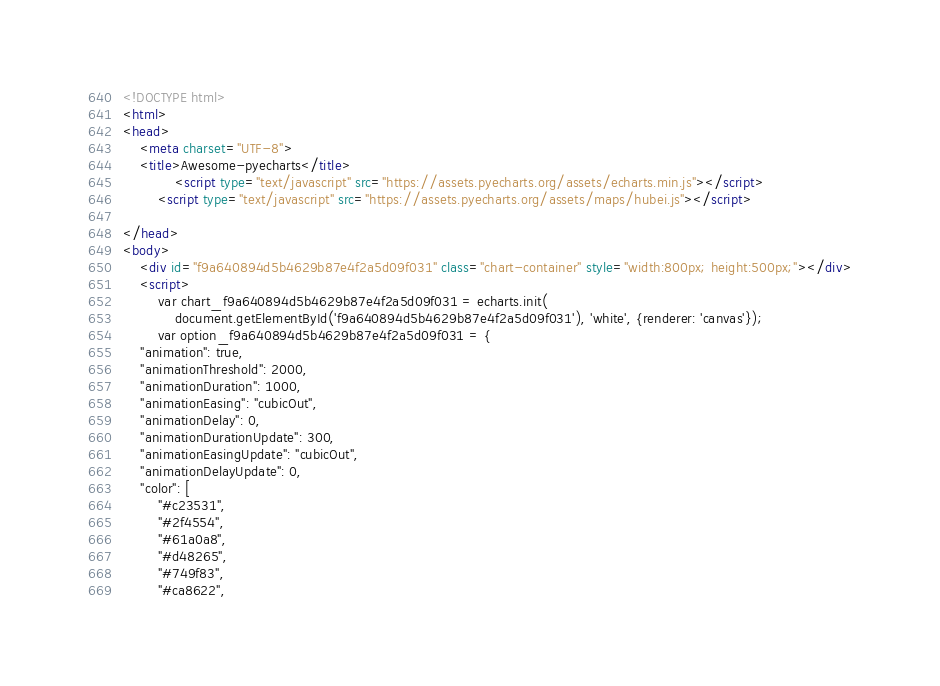<code> <loc_0><loc_0><loc_500><loc_500><_HTML_><!DOCTYPE html>
<html>
<head>
    <meta charset="UTF-8">
    <title>Awesome-pyecharts</title>
            <script type="text/javascript" src="https://assets.pyecharts.org/assets/echarts.min.js"></script>
        <script type="text/javascript" src="https://assets.pyecharts.org/assets/maps/hubei.js"></script>

</head>
<body>
    <div id="f9a640894d5b4629b87e4f2a5d09f031" class="chart-container" style="width:800px; height:500px;"></div>
    <script>
        var chart_f9a640894d5b4629b87e4f2a5d09f031 = echarts.init(
            document.getElementById('f9a640894d5b4629b87e4f2a5d09f031'), 'white', {renderer: 'canvas'});
        var option_f9a640894d5b4629b87e4f2a5d09f031 = {
    "animation": true,
    "animationThreshold": 2000,
    "animationDuration": 1000,
    "animationEasing": "cubicOut",
    "animationDelay": 0,
    "animationDurationUpdate": 300,
    "animationEasingUpdate": "cubicOut",
    "animationDelayUpdate": 0,
    "color": [
        "#c23531",
        "#2f4554",
        "#61a0a8",
        "#d48265",
        "#749f83",
        "#ca8622",</code> 